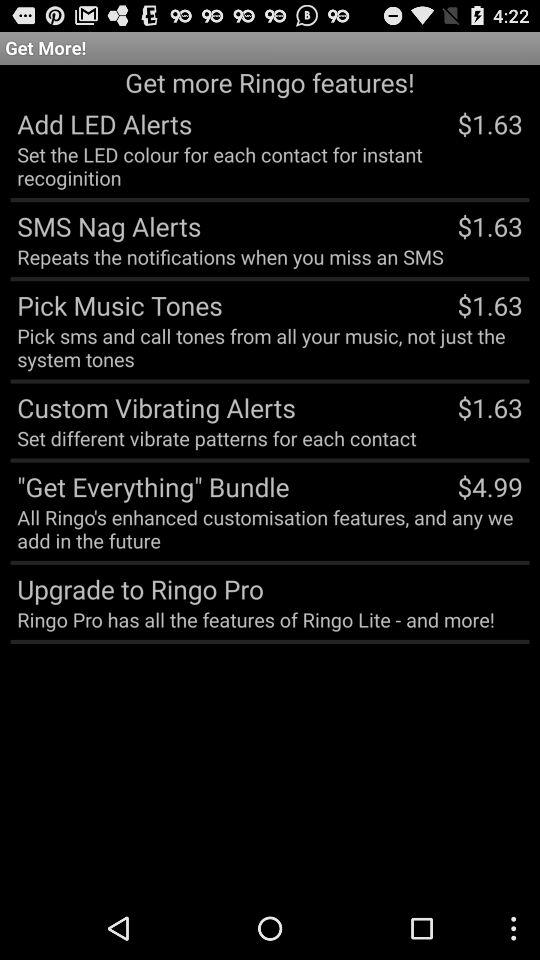What is the price of the "SMS Nag Alerts"? The price is $1.63. 